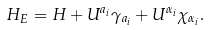<formula> <loc_0><loc_0><loc_500><loc_500>H _ { E } = H + U ^ { a _ { i } } \gamma _ { a _ { i } } + U ^ { \alpha _ { i } } \chi _ { \alpha _ { i } } .</formula> 